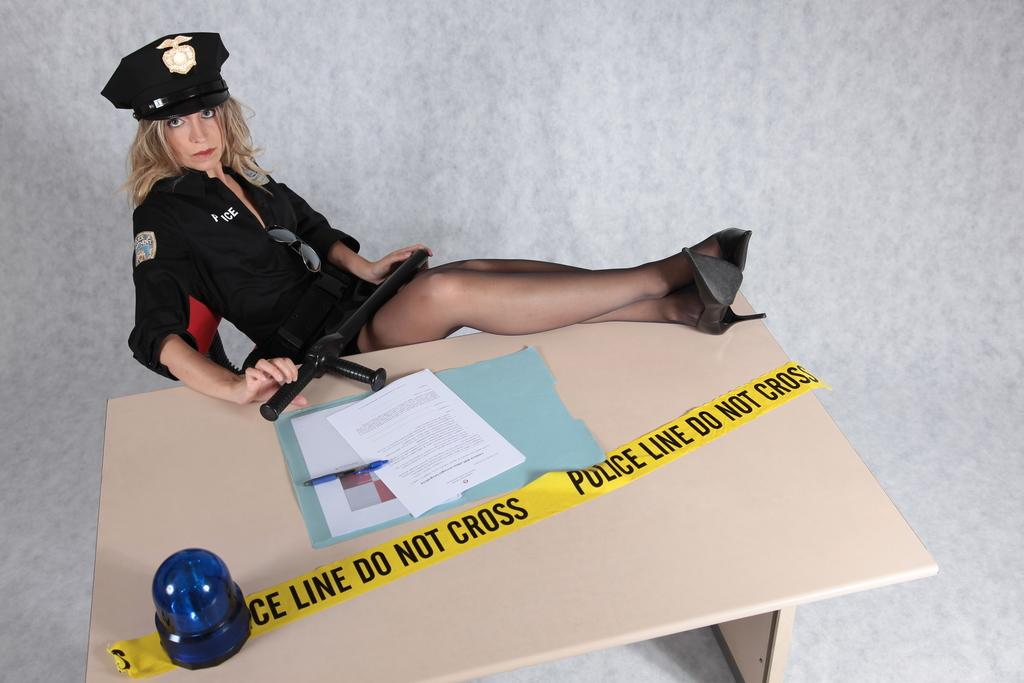Who is present in the image? There is a woman in the image. What is the woman doing in the image? The woman is sitting on a chair. What objects can be seen on the table in the image? There is a paper and a pen on the table. How many mice are running around on the table in the image? There are no mice present in the image; only a woman, a chair, a table, a paper, and a pen can be seen. 